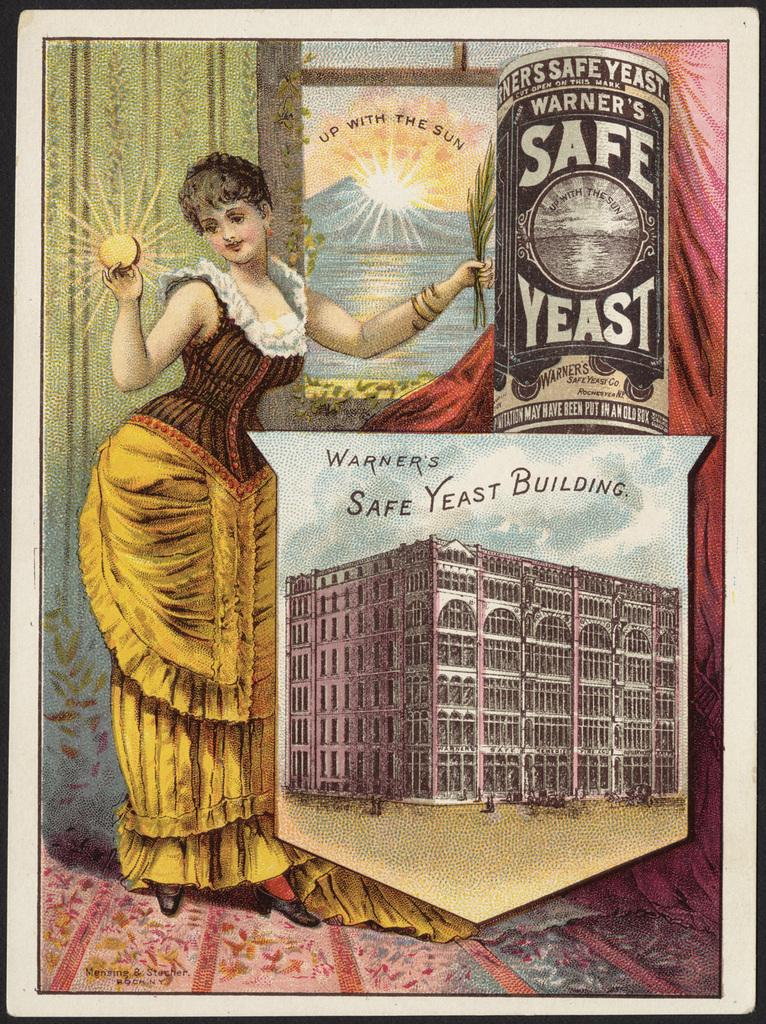<image>
Give a short and clear explanation of the subsequent image. A lady in a dress is posing with Warner's Safe Yeast and holding a sun in her right hand. 